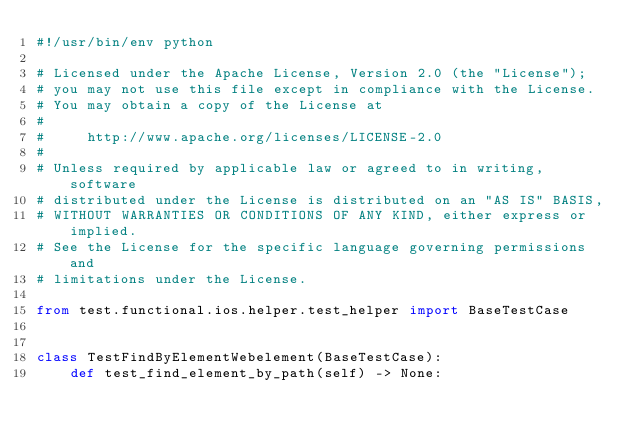Convert code to text. <code><loc_0><loc_0><loc_500><loc_500><_Python_>#!/usr/bin/env python

# Licensed under the Apache License, Version 2.0 (the "License");
# you may not use this file except in compliance with the License.
# You may obtain a copy of the License at
#
#     http://www.apache.org/licenses/LICENSE-2.0
#
# Unless required by applicable law or agreed to in writing, software
# distributed under the License is distributed on an "AS IS" BASIS,
# WITHOUT WARRANTIES OR CONDITIONS OF ANY KIND, either express or implied.
# See the License for the specific language governing permissions and
# limitations under the License.

from test.functional.ios.helper.test_helper import BaseTestCase


class TestFindByElementWebelement(BaseTestCase):
    def test_find_element_by_path(self) -> None:</code> 